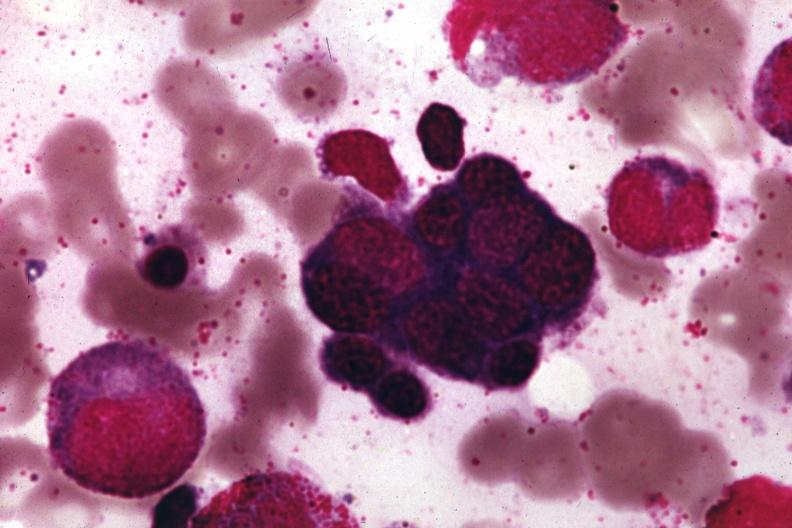what is present?
Answer the question using a single word or phrase. Megaloblastic erythrocytes pernicious anemia 